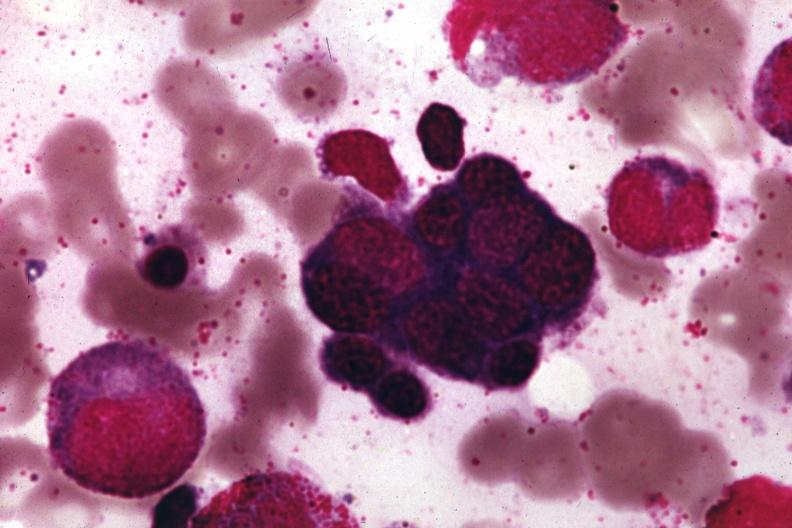what is present?
Answer the question using a single word or phrase. Megaloblastic erythrocytes pernicious anemia 